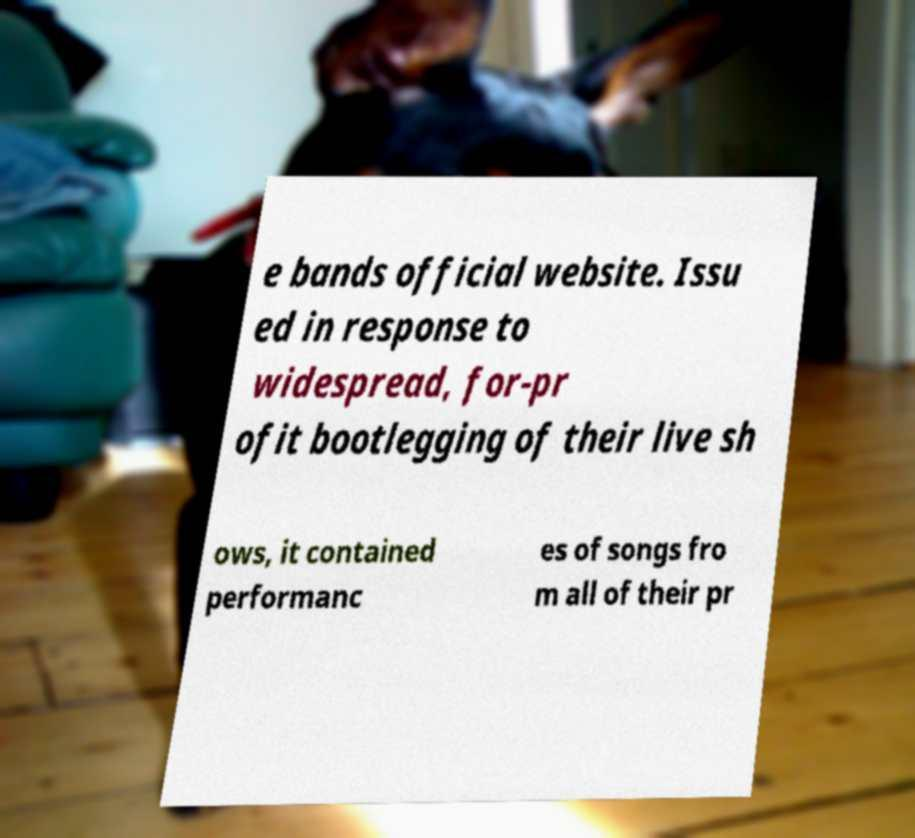Please identify and transcribe the text found in this image. e bands official website. Issu ed in response to widespread, for-pr ofit bootlegging of their live sh ows, it contained performanc es of songs fro m all of their pr 